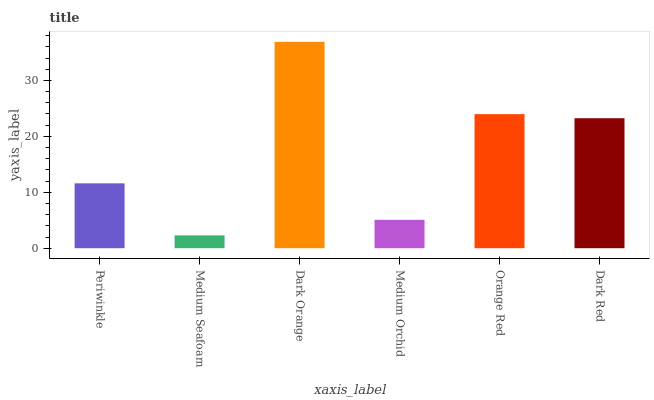Is Medium Seafoam the minimum?
Answer yes or no. Yes. Is Dark Orange the maximum?
Answer yes or no. Yes. Is Dark Orange the minimum?
Answer yes or no. No. Is Medium Seafoam the maximum?
Answer yes or no. No. Is Dark Orange greater than Medium Seafoam?
Answer yes or no. Yes. Is Medium Seafoam less than Dark Orange?
Answer yes or no. Yes. Is Medium Seafoam greater than Dark Orange?
Answer yes or no. No. Is Dark Orange less than Medium Seafoam?
Answer yes or no. No. Is Dark Red the high median?
Answer yes or no. Yes. Is Periwinkle the low median?
Answer yes or no. Yes. Is Periwinkle the high median?
Answer yes or no. No. Is Dark Red the low median?
Answer yes or no. No. 